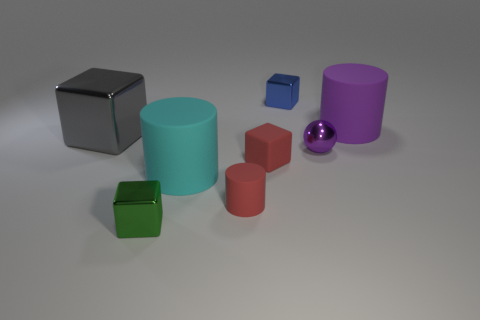Subtract all cyan blocks. Subtract all yellow spheres. How many blocks are left? 4 Add 1 green metal spheres. How many objects exist? 9 Subtract all cylinders. How many objects are left? 5 Add 8 purple metal spheres. How many purple metal spheres exist? 9 Subtract 0 blue spheres. How many objects are left? 8 Subtract all cyan metal cubes. Subtract all cyan cylinders. How many objects are left? 7 Add 1 big objects. How many big objects are left? 4 